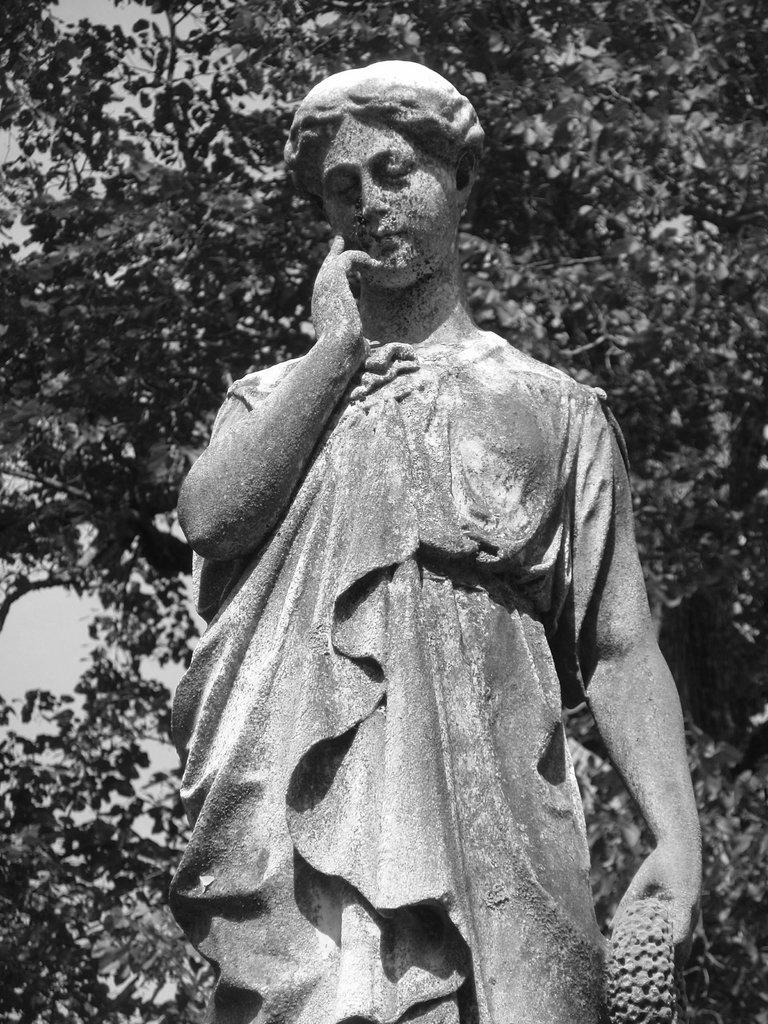What is the color scheme of the image? The image is black and white. What is the main subject of the image? There is a statue of a woman in the image. What can be seen in the background of the image? Trees and the sky are visible in the background of the image. What type of fuel is being used by the question in the image? There is no question present in the image, and therefore no fuel is being used. 